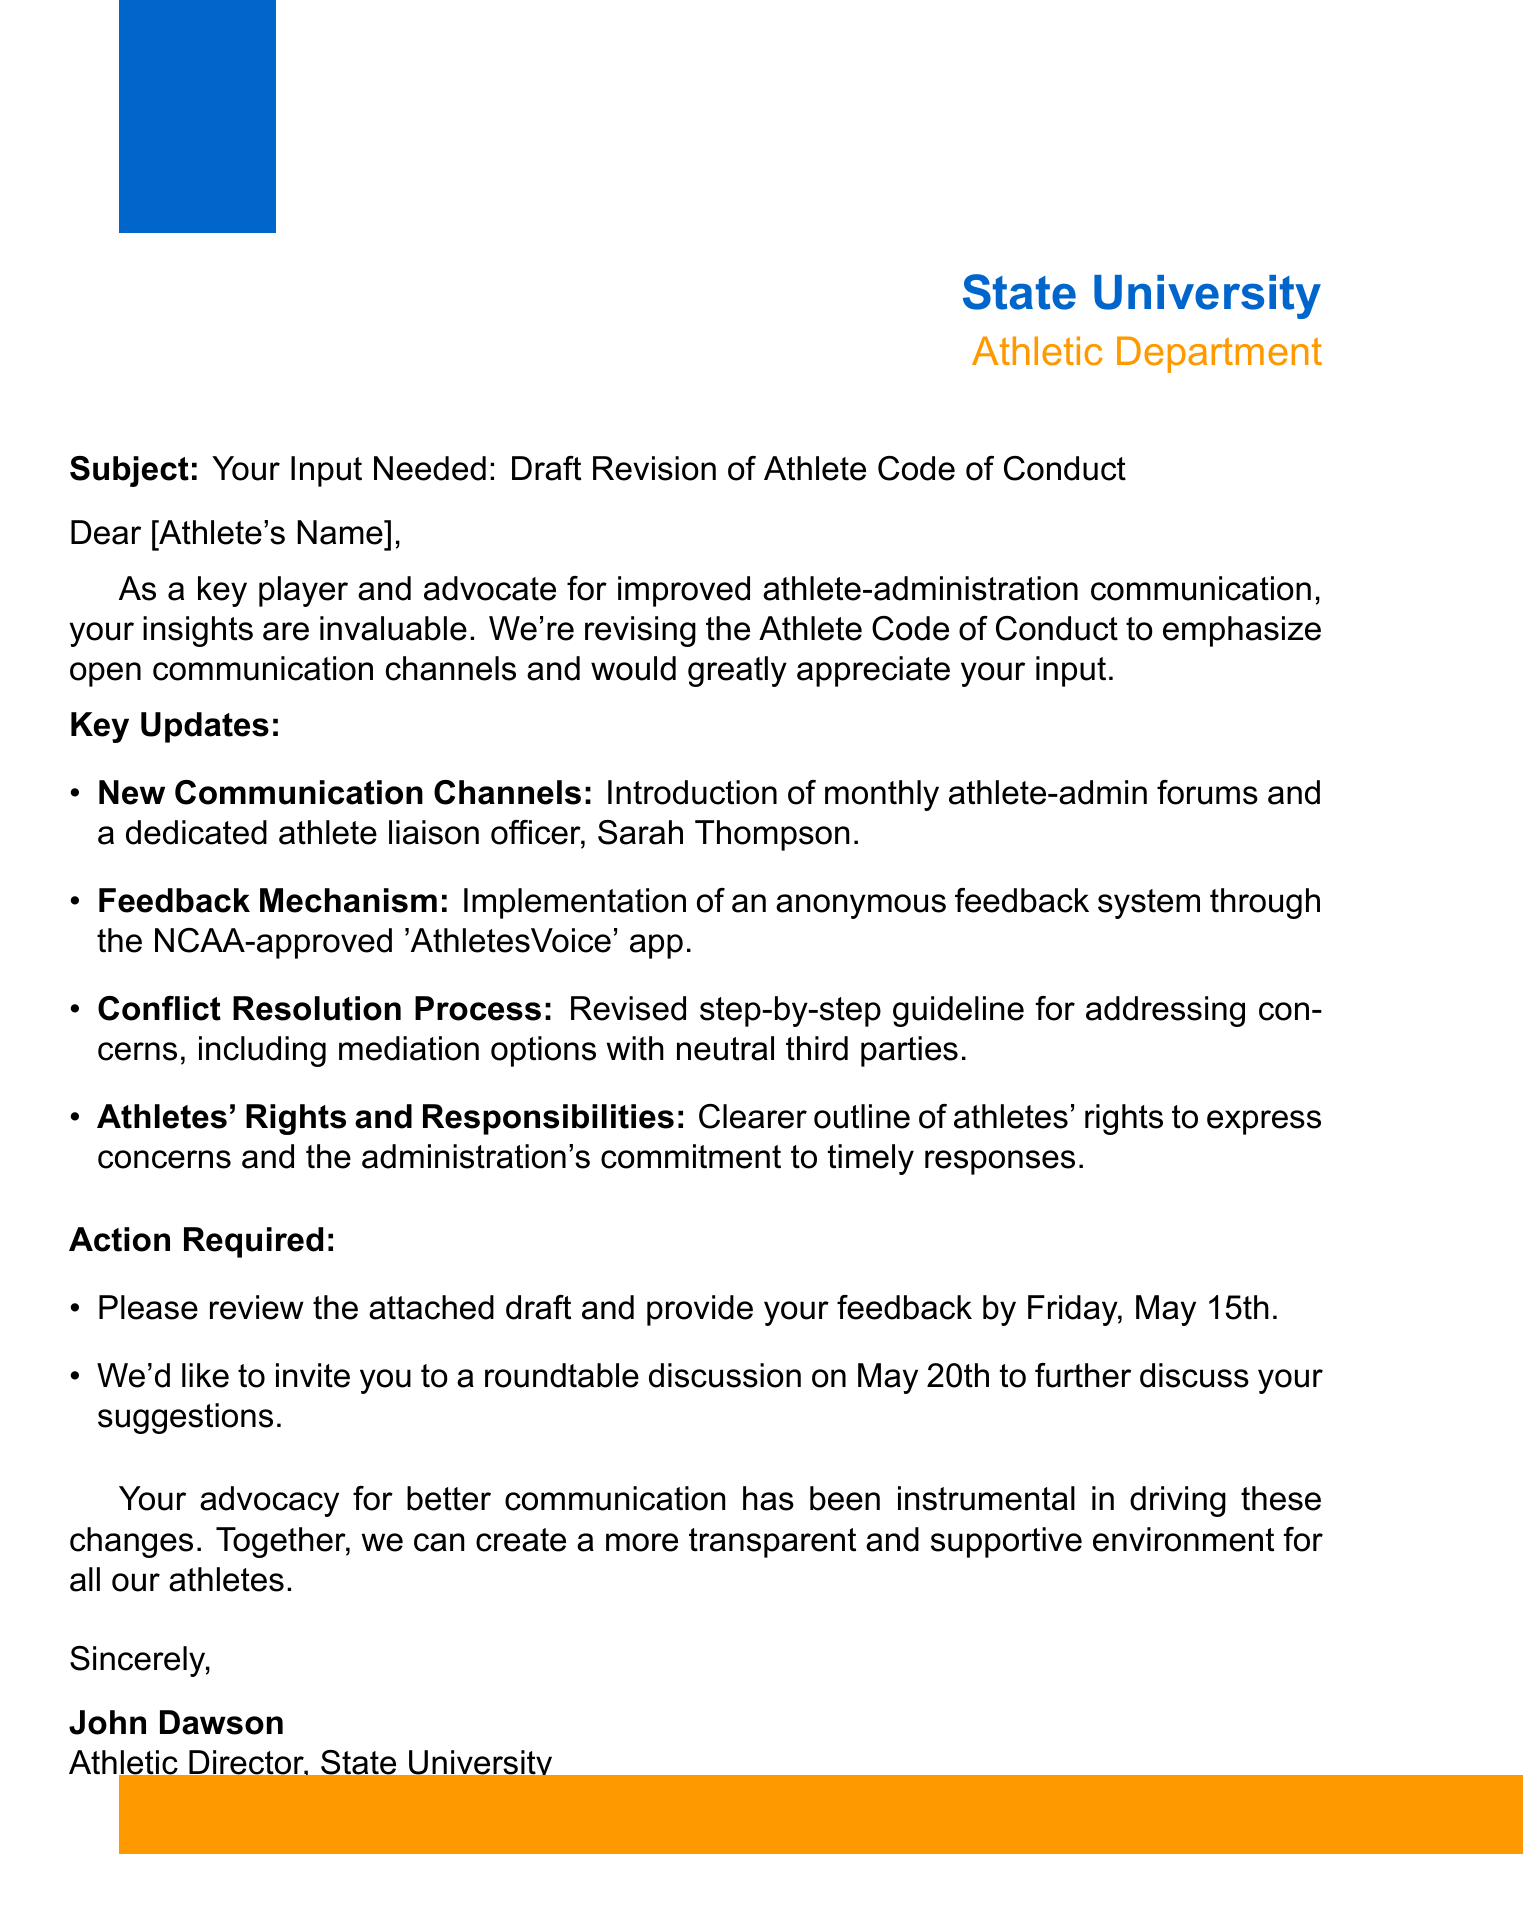What is the subject of the email? The subject clearly states the purpose of the email regarding the revision of the Athlete Code of Conduct.
Answer: Your Input Needed: Draft Revision of Athlete Code of Conduct Who is the dedicated athlete liaison officer mentioned? The document specifies the name of the athlete liaison officer as part of the new communication initiatives.
Answer: Sarah Thompson What is the deadline for providing feedback on the draft? The document outlines a specific deadline for feedback from the athletes.
Answer: Friday, May 15th What is the purpose of the 'AthletesVoice' app? The document describes the app as a system for gathering feedback from athletes anonymously.
Answer: Feedback mechanism When is the roundtable discussion scheduled? The email invites athletes to a discussion to engage further on the subject, specifying the date.
Answer: May 20th How does the revised code address conflict resolution? The document refers to a revised guideline that provides a clear process for conflict resolution.
Answer: Mediation options with neutral third parties What key topic emphasizes athlete-administration communication? The document explicitly states that the revision focuses on improving communication channels between athletes and administration.
Answer: New Communication Channels What is the main goal of the revised Athlete Code of Conduct? The introduction of the document highlights the major aim of emphasizing communication.
Answer: Better communication channels 